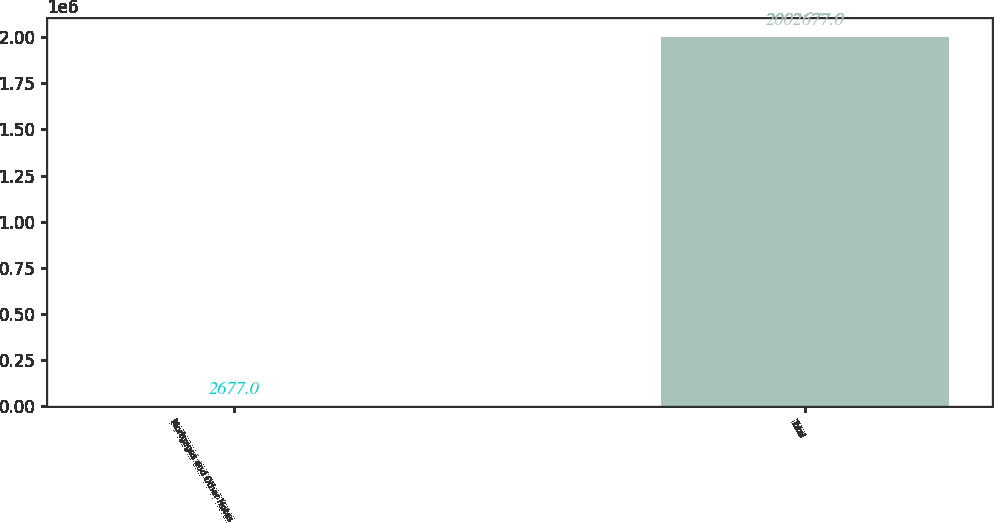Convert chart to OTSL. <chart><loc_0><loc_0><loc_500><loc_500><bar_chart><fcel>Mortgages and Other Notes<fcel>Total<nl><fcel>2677<fcel>2.00268e+06<nl></chart> 